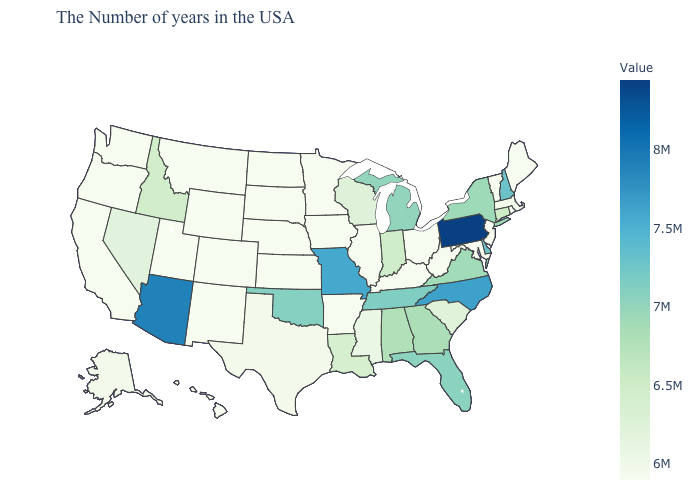Does the map have missing data?
Be succinct. No. Among the states that border Idaho , does Nevada have the lowest value?
Be succinct. No. Which states have the highest value in the USA?
Be succinct. Pennsylvania. Does New York have the lowest value in the Northeast?
Quick response, please. No. Does the map have missing data?
Give a very brief answer. No. 